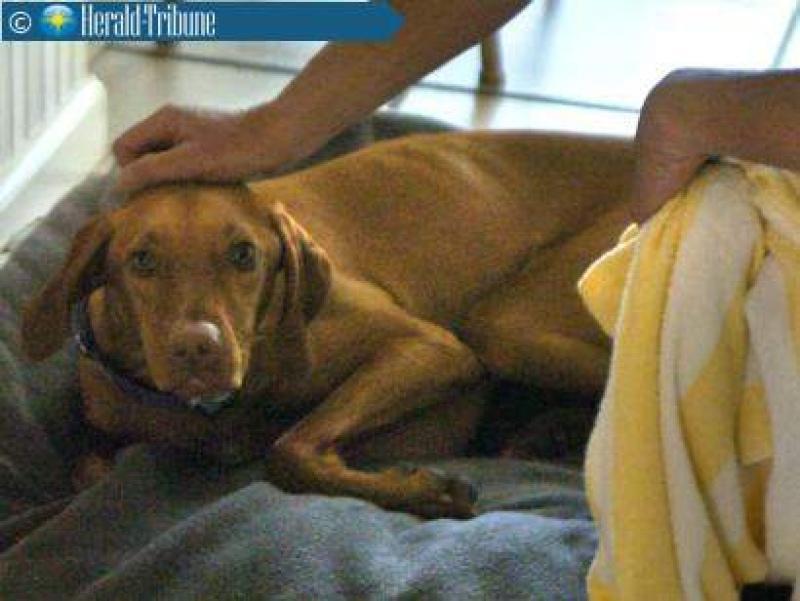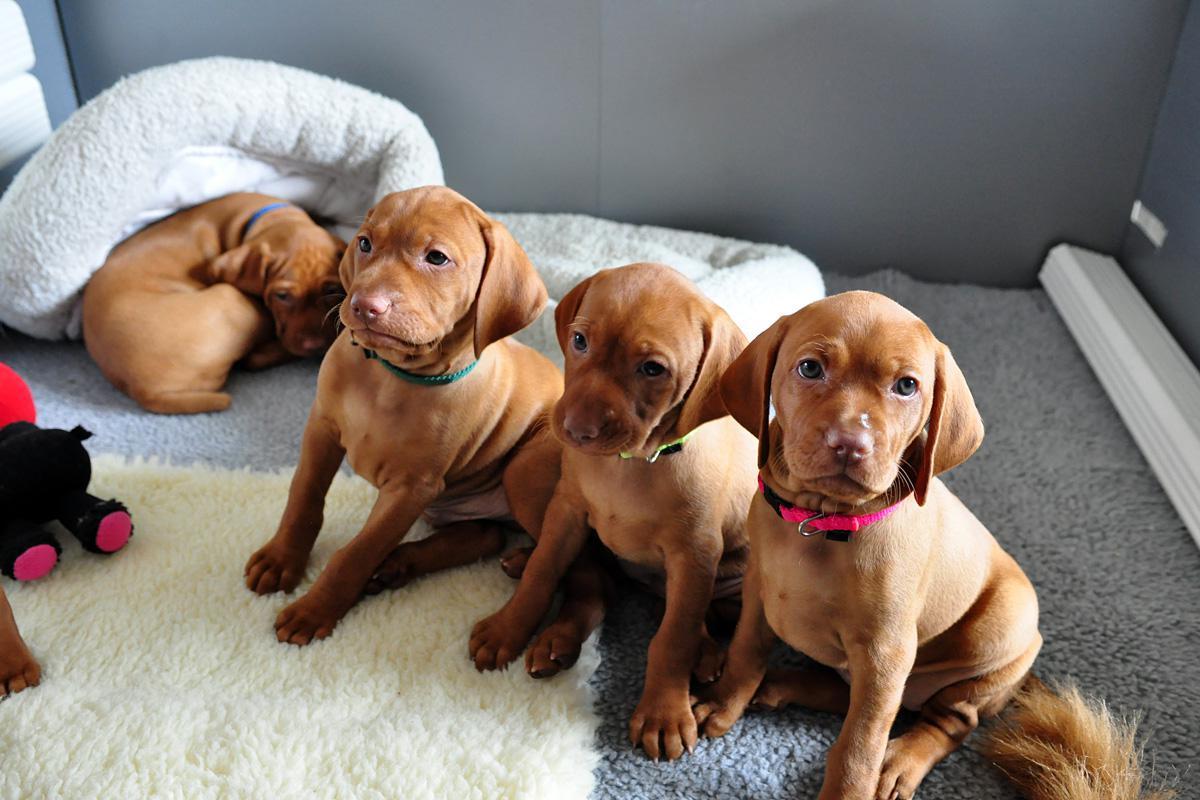The first image is the image on the left, the second image is the image on the right. For the images shown, is this caption "In at least one image there is a single puppy whose face is tilted left." true? Answer yes or no. No. The first image is the image on the left, the second image is the image on the right. Considering the images on both sides, is "There are at most 5 dogs in total." valid? Answer yes or no. Yes. 